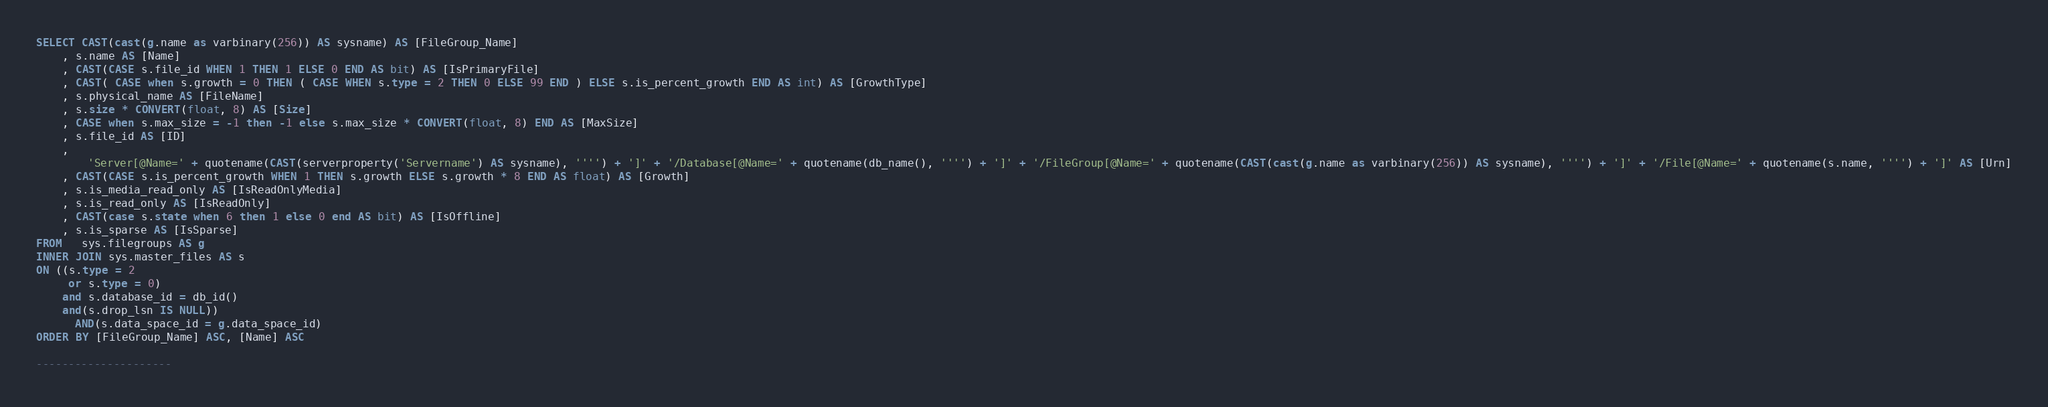<code> <loc_0><loc_0><loc_500><loc_500><_SQL_>SELECT CAST(cast(g.name as varbinary(256)) AS sysname) AS [FileGroup_Name]
    , s.name AS [Name]
    , CAST(CASE s.file_id WHEN 1 THEN 1 ELSE 0 END AS bit) AS [IsPrimaryFile]
    , CAST( CASE when s.growth = 0 THEN ( CASE WHEN s.type = 2 THEN 0 ELSE 99 END ) ELSE s.is_percent_growth END AS int) AS [GrowthType]
    , s.physical_name AS [FileName]
    , s.size * CONVERT(float, 8) AS [Size]
    , CASE when s.max_size = -1 then -1 else s.max_size * CONVERT(float, 8) END AS [MaxSize]
    , s.file_id AS [ID]
    ,
        'Server[@Name=' + quotename(CAST(serverproperty('Servername') AS sysname), '''') + ']' + '/Database[@Name=' + quotename(db_name(), '''') + ']' + '/FileGroup[@Name=' + quotename(CAST(cast(g.name as varbinary(256)) AS sysname), '''') + ']' + '/File[@Name=' + quotename(s.name, '''') + ']' AS [Urn]
    , CAST(CASE s.is_percent_growth WHEN 1 THEN s.growth ELSE s.growth * 8 END AS float) AS [Growth]
    , s.is_media_read_only AS [IsReadOnlyMedia]
    , s.is_read_only AS [IsReadOnly]
    , CAST(case s.state when 6 then 1 else 0 end AS bit) AS [IsOffline]
    , s.is_sparse AS [IsSparse]
FROM   sys.filegroups AS g
INNER JOIN sys.master_files AS s
ON ((s.type = 2
     or s.type = 0)
    and s.database_id = db_id()
    and(s.drop_lsn IS NULL))
      AND(s.data_space_id = g.data_space_id)
ORDER BY [FileGroup_Name] ASC, [Name] ASC

---------------------
</code> 